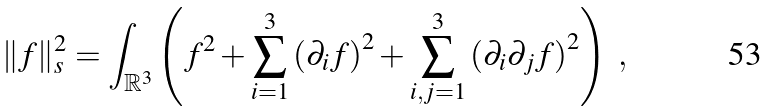Convert formula to latex. <formula><loc_0><loc_0><loc_500><loc_500>\| f \| _ { s } ^ { 2 } = \int _ { \mathbb { R } ^ { 3 } } \left ( f ^ { 2 } + \sum _ { i = 1 } ^ { 3 } \left ( \partial _ { i } f \right ) ^ { 2 } + \sum _ { i , j = 1 } ^ { 3 } \left ( \partial _ { i } \partial _ { j } f \right ) ^ { 2 } \right ) \ ,</formula> 